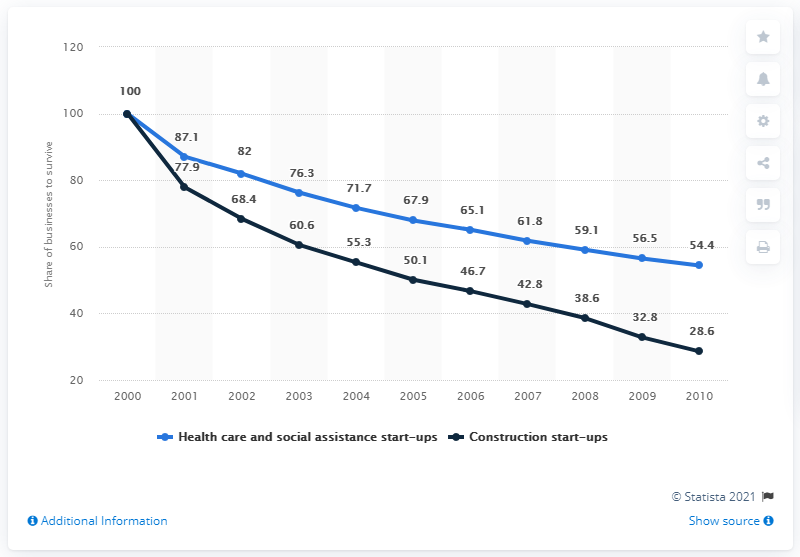In which year did the black line graph saw its highest peak? According to the displayed line graph, the black line, which represents construction start-ups, reached its highest peak in the year 2000 at a value of 100 share of businesses in the United States. 